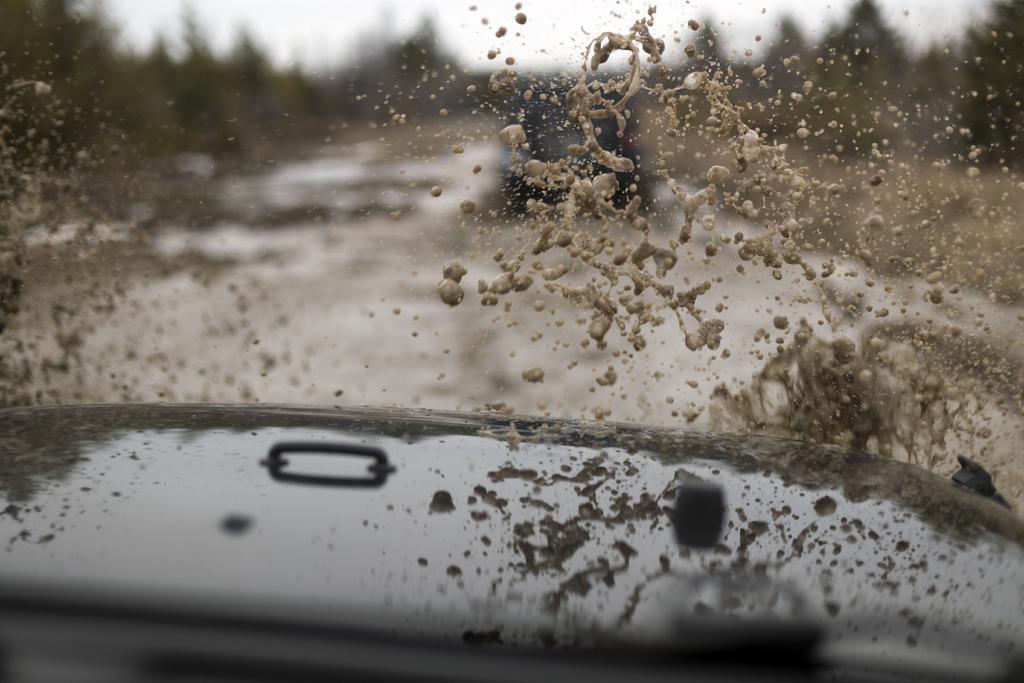Can you describe this image briefly? In the background of the image there are trees. There is a car on the road. In the center of the image there is water. At the bottom of the image there is car. 